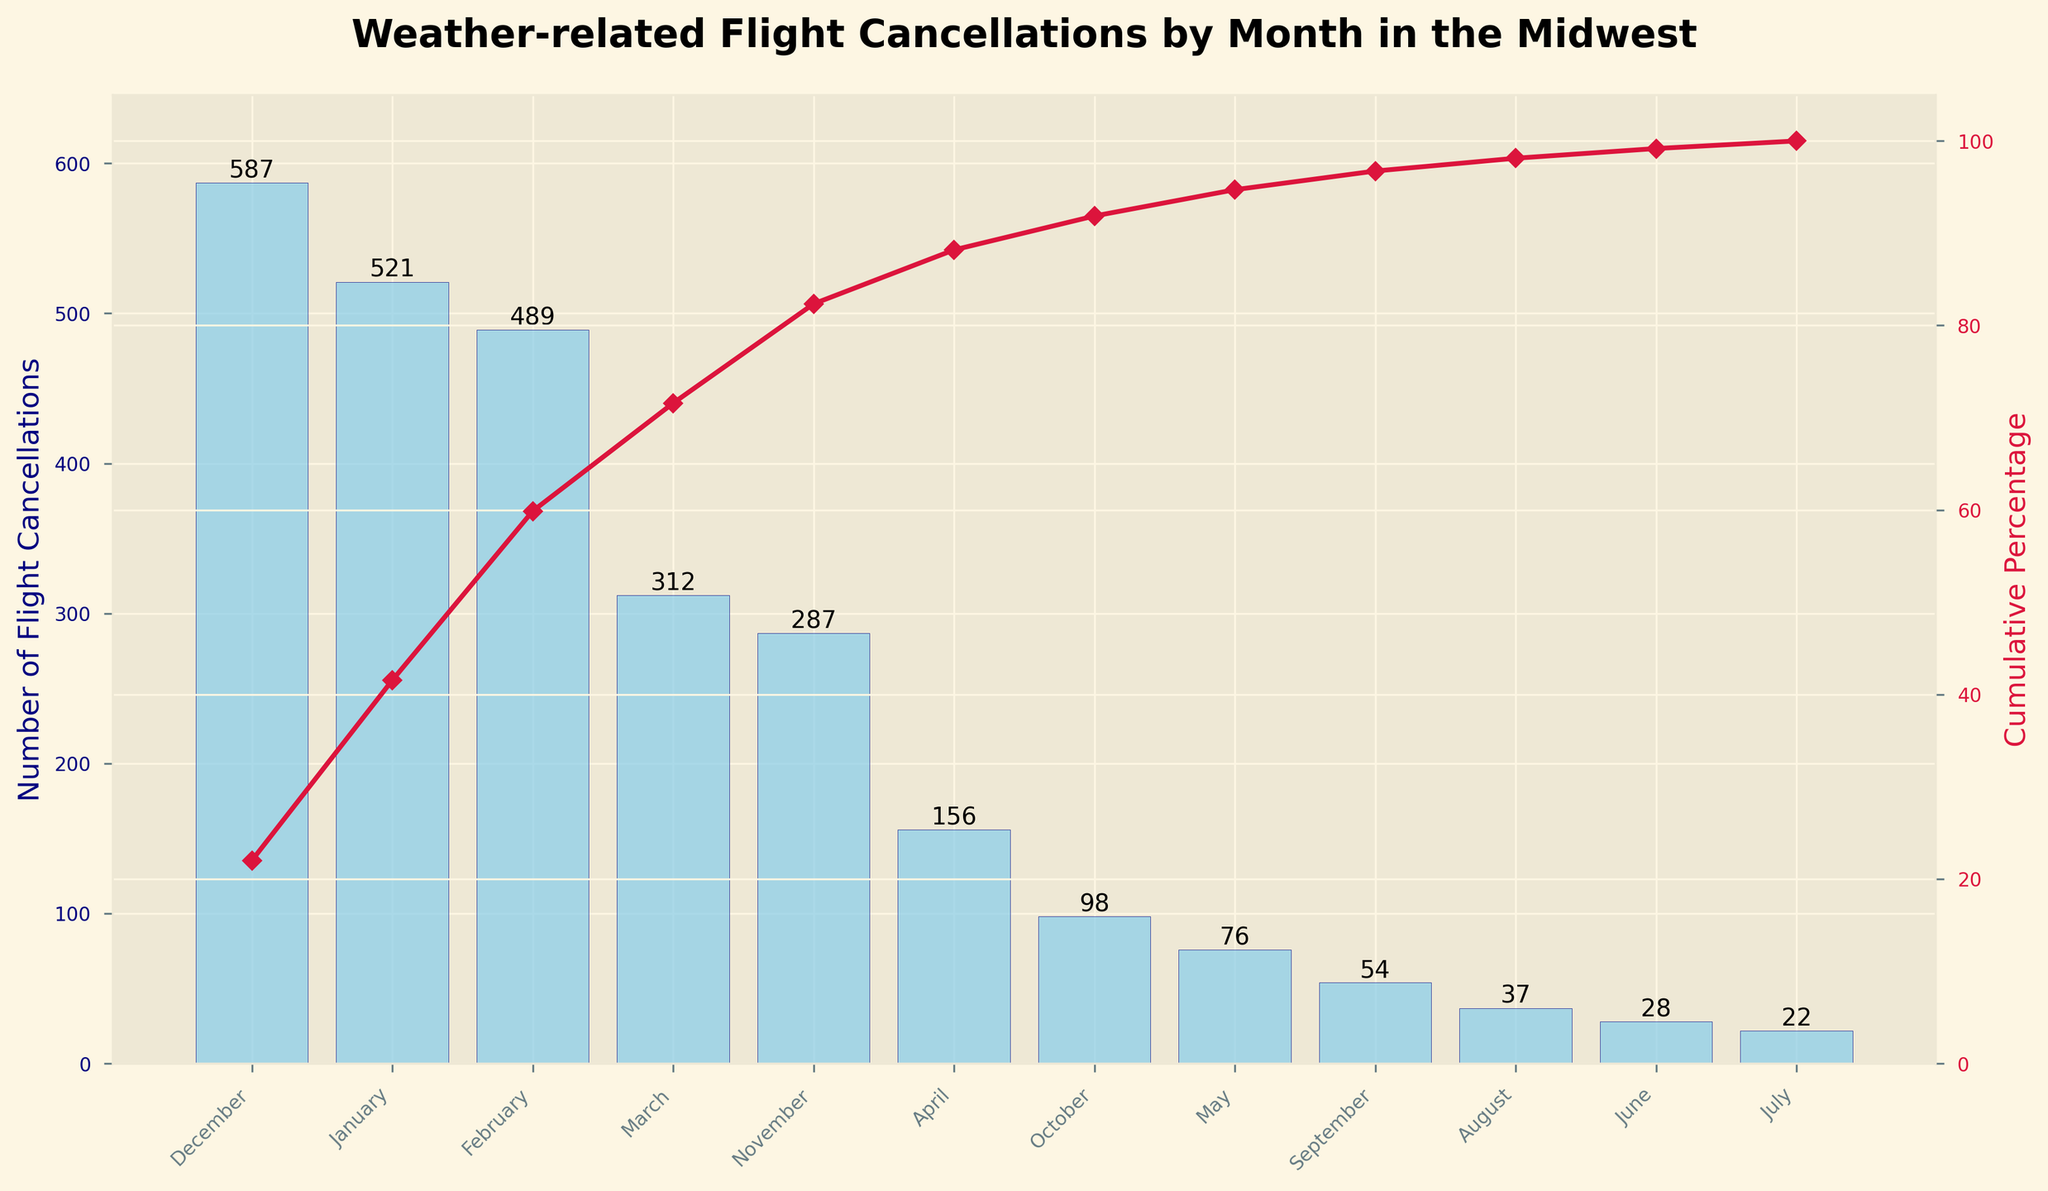What month had the highest number of weather-related flight cancellations? The bar corresponding to December is the tallest, indicating the highest number of cancellations.
Answer: December Which month had the lowest number of weather-related flight cancellations? The shortest bar represents July, indicating the lowest number of cancellations.
Answer: July Around what percentage of total flight cancellations occurred by the end of March? The line for cumulative percentage at March is closest to the 50% mark on the secondary y-axis.
Answer: About 55% How many flight cancellations were there in January and February combined? January had 521 cancellations and February had 489. Adding these, 521 + 489 = 1,010
Answer: 1,010 Which months had more than 300 but fewer than 600 flight cancellations? The bars for December, January, February, and March fit this range but November does not, as it had fewer than 300 cancellations.
Answer: December, January, February, March Which month had flight cancellations 100 less than October? October had 98 cancellations. Finding a number approximately 100 less, July matches this condition with 22 cancellations (98 - 76).
Answer: July By June, what percentage of total flight cancellations had been accounted for? The line for cumulative percentage at June shows slightly below the 97% mark on the right y-axis.
Answer: About 87% What is the difference in the number of cancellations between November and April? November had 287 cancellations, and April had 156. The difference is 287 - 156 = 131
Answer: 131 What proportion of total cancellations occurred in the first three months of the year (January, February, and March)? Adding cancellations for January (521), February (489), and March (312), we get 521 + 489 + 312 = 1,322. The total cancellations are 2,667. The proportion is (1,322/2,667) ≈ 0.496, or about 50%.
Answer: About 50% What is the cumulative percentage of flight cancellations by November? On the cumulative percentage line, it is roughly 80% by November.
Answer: About 70% 